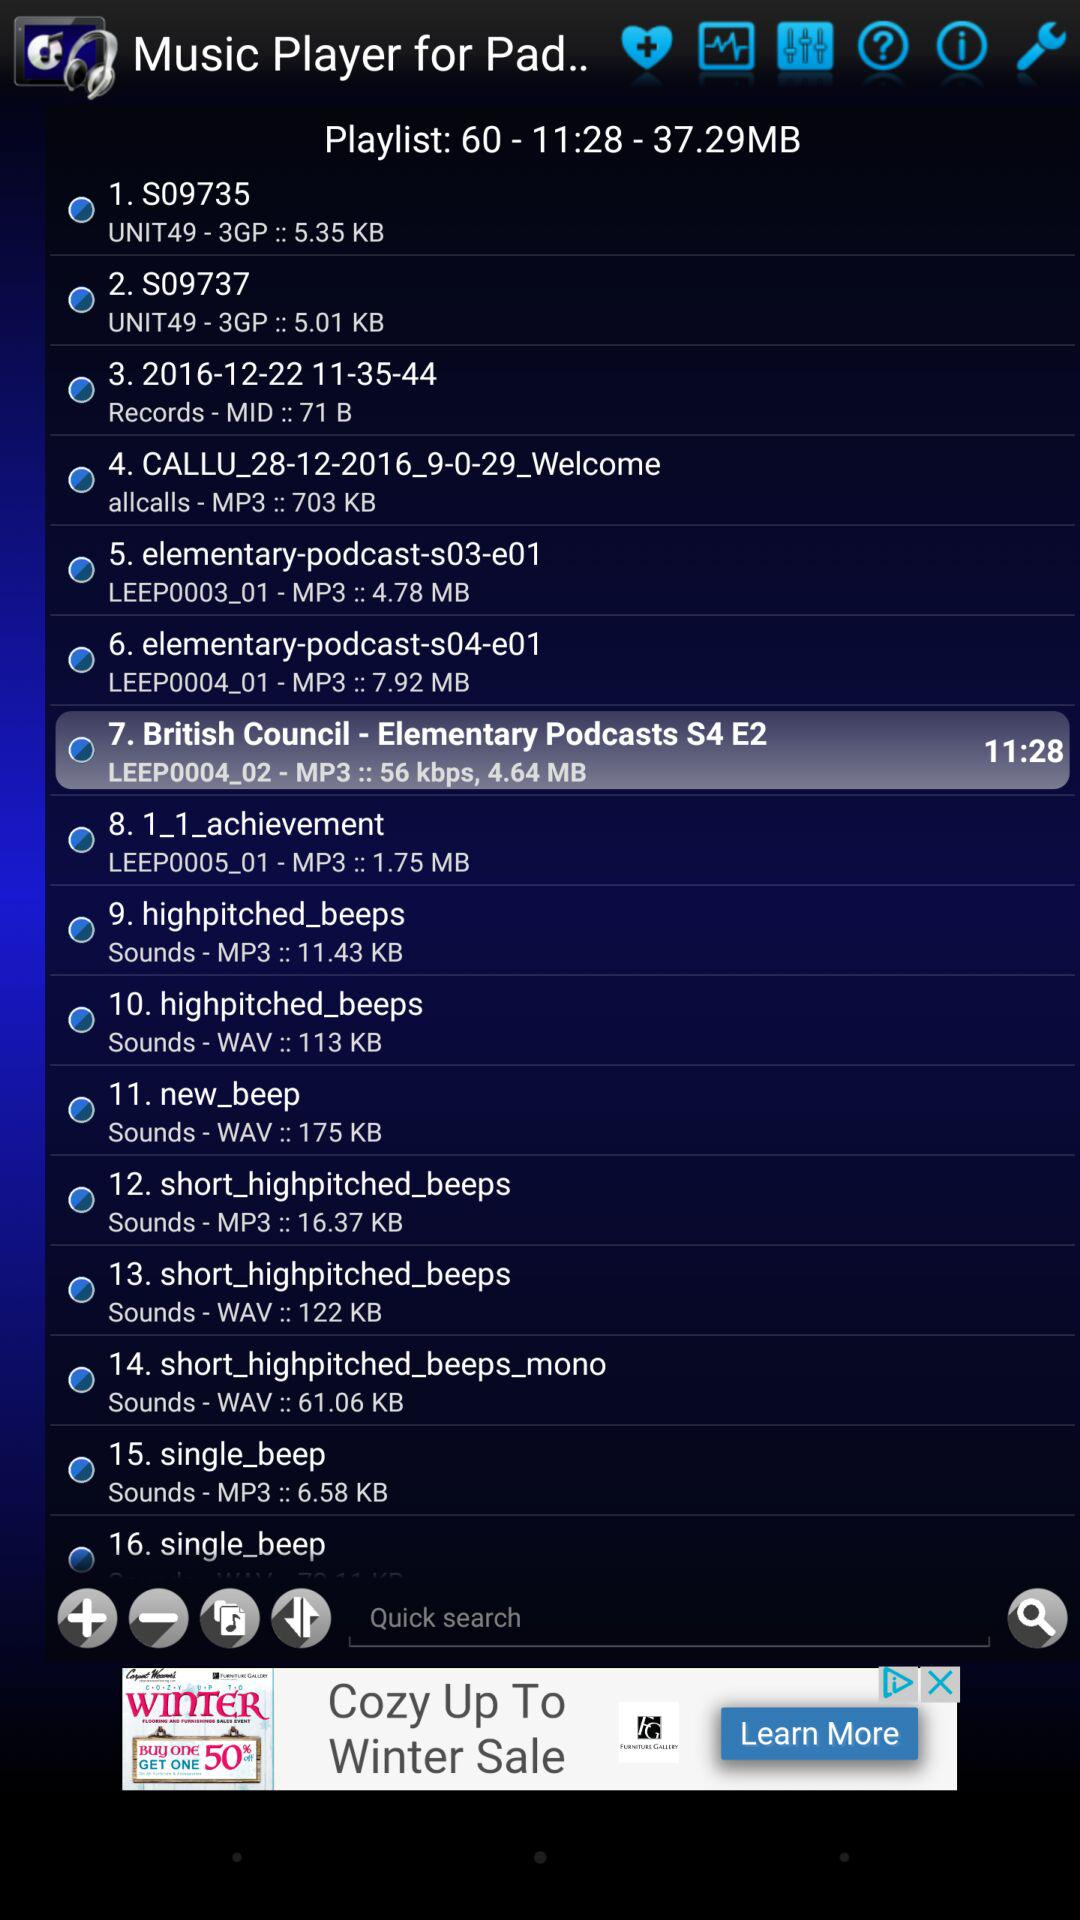What's the total size of the playlist? The total size of the playlist is 37.29 MB. 